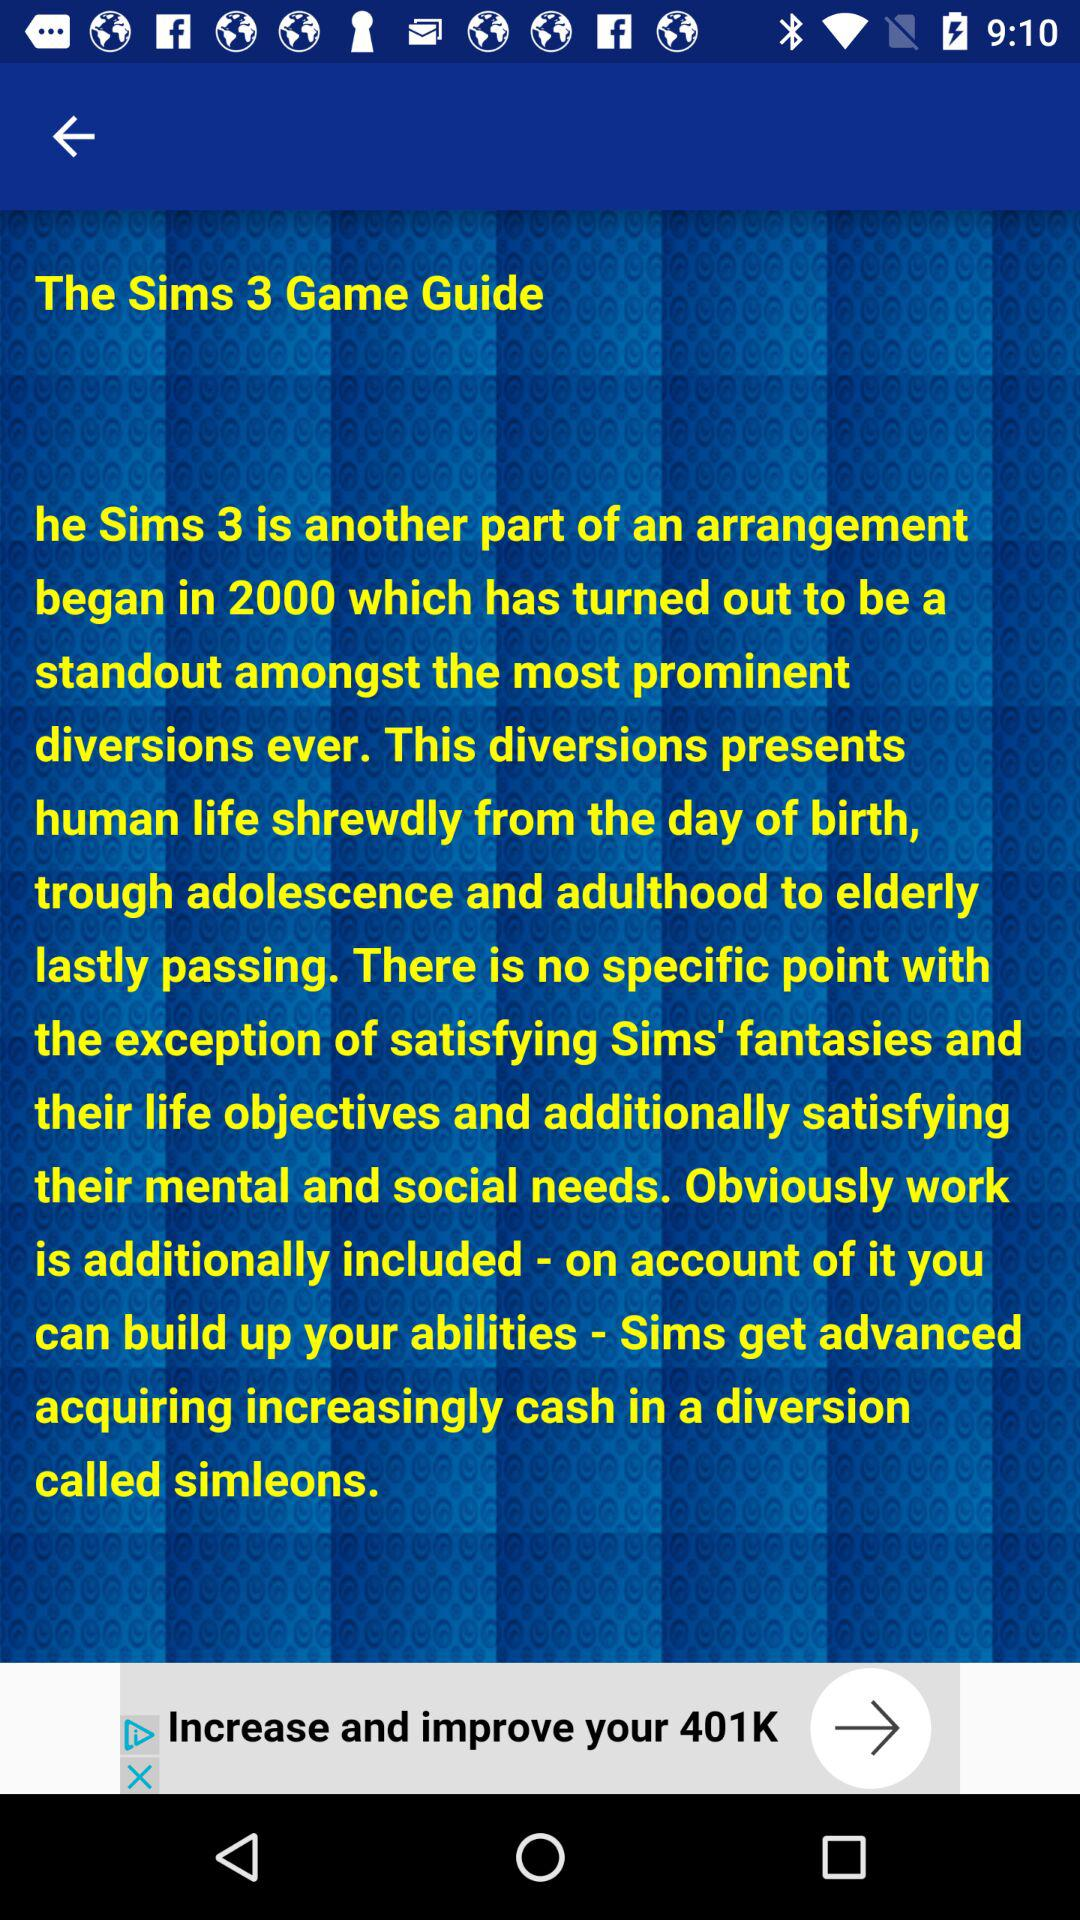What is the app name? The app name is "The Sims 3 Game Guide". 